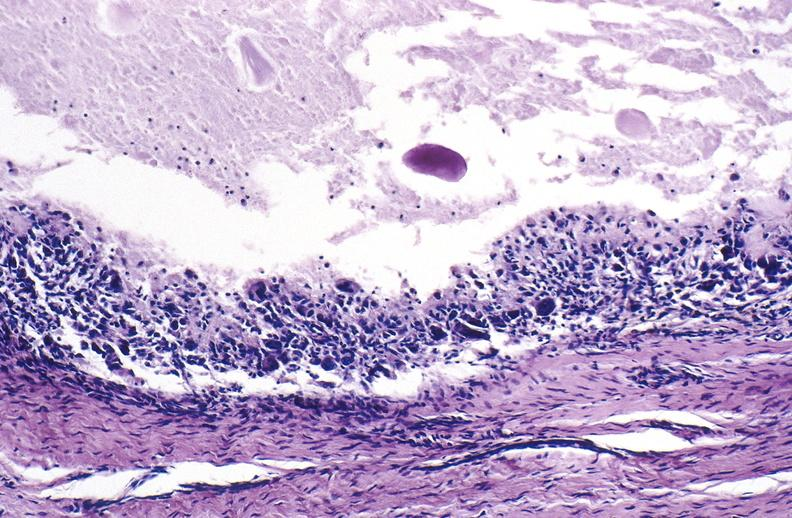what is present?
Answer the question using a single word or phrase. Joints 